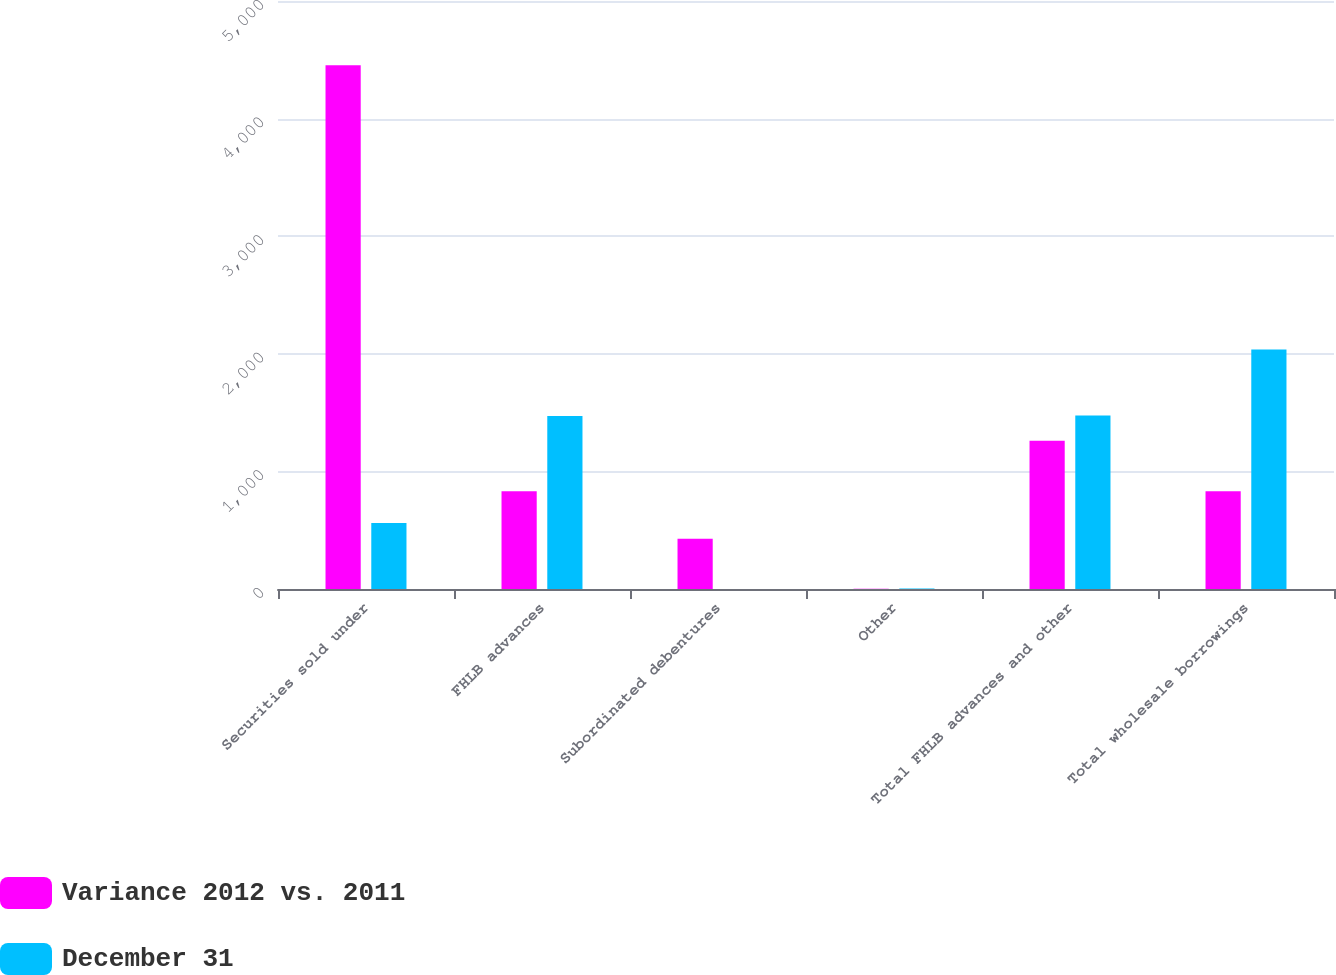Convert chart. <chart><loc_0><loc_0><loc_500><loc_500><stacked_bar_chart><ecel><fcel>Securities sold under<fcel>FHLB advances<fcel>Subordinated debentures<fcel>Other<fcel>Total FHLB advances and other<fcel>Total wholesale borrowings<nl><fcel>Variance 2012 vs. 2011<fcel>4454.7<fcel>831.7<fcel>427.7<fcel>1.5<fcel>1260.9<fcel>831.7<nl><fcel>December 31<fcel>560.8<fcel>1471<fcel>0.1<fcel>5.1<fcel>1476<fcel>2036.8<nl></chart> 